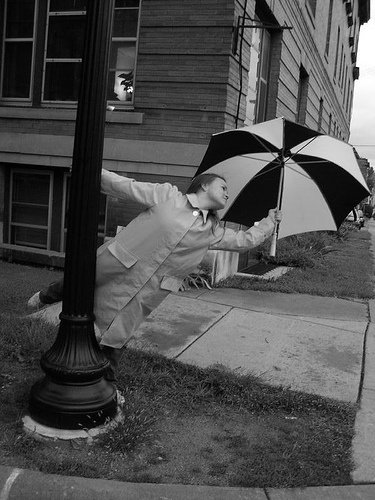Describe the objects in this image and their specific colors. I can see people in black, gray, darkgray, and lightgray tones and umbrella in black, darkgray, lightgray, and gray tones in this image. 